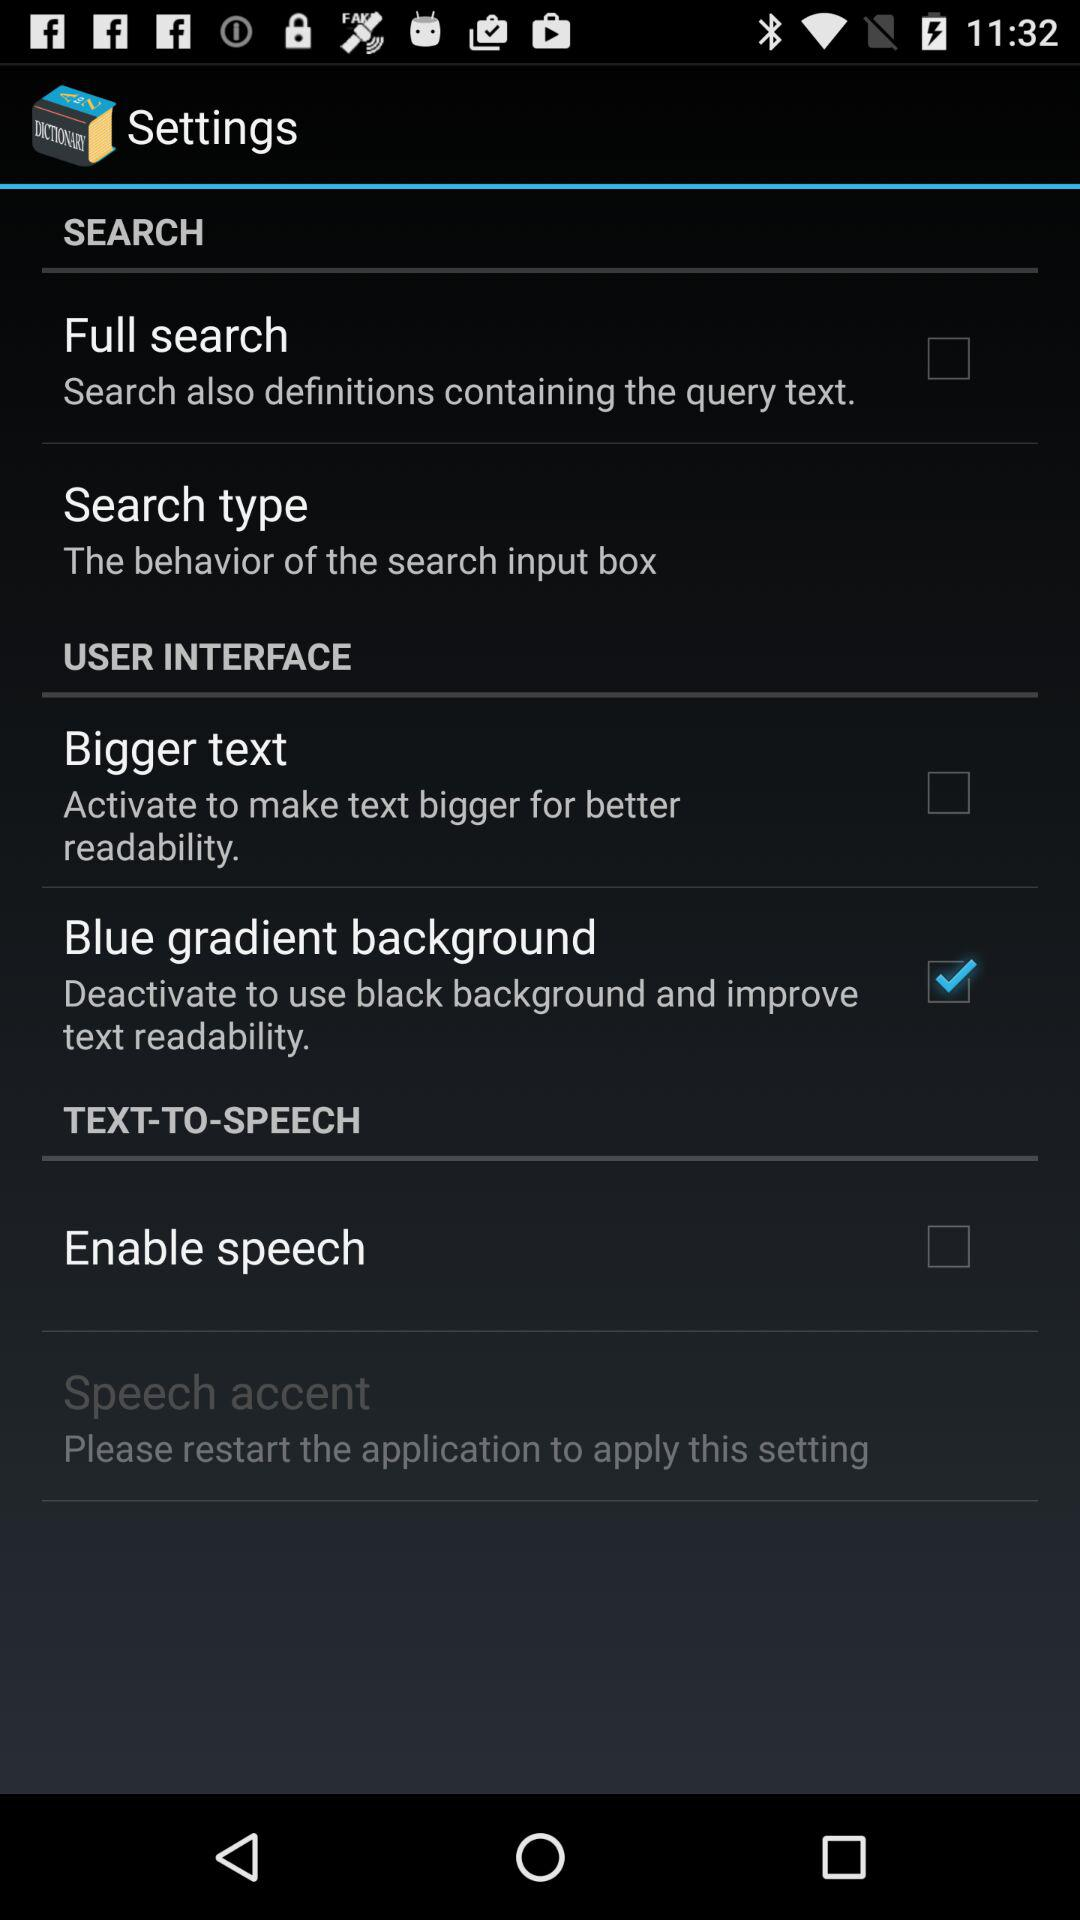What is the status of "Blue gradient background"? The status is "on". 